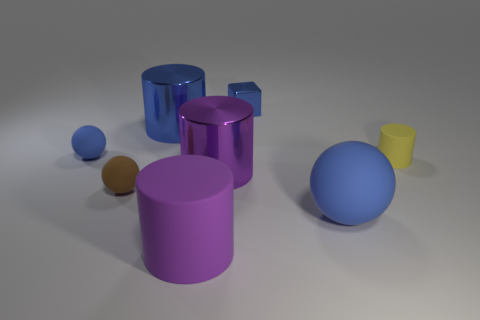What colors are present in the objects? The objects exhibit a variety of colors including blue, purple, yellow, and brown. 